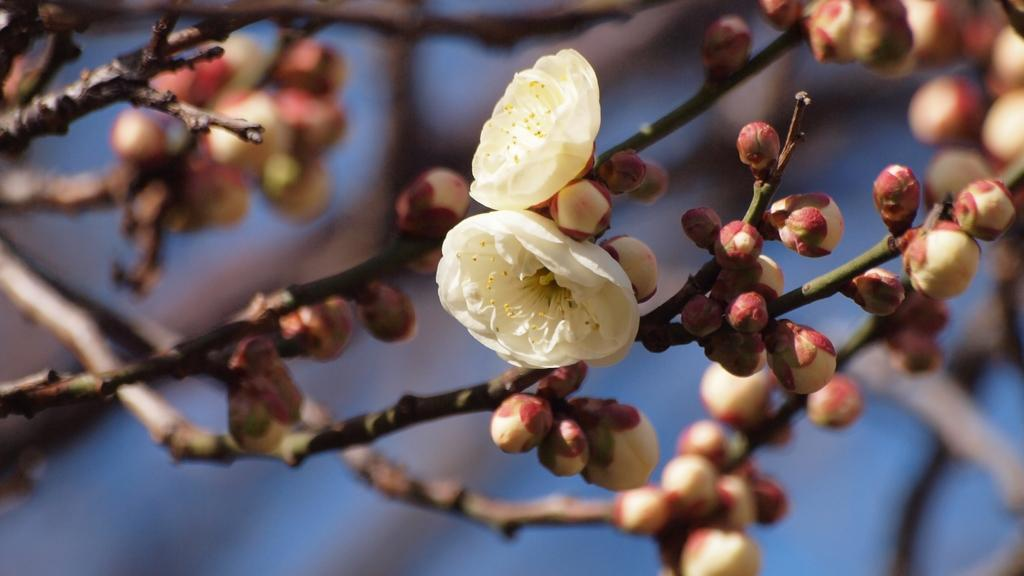How many flowers can be seen in the image? There are two flowers in the image. What color are the flowers? The flowers are cream-colored. Are there any unopened flowers on the plant? Yes, there are flower buds on the plant. What can be observed about the background of the image? The background of the image is blurred. What is the opinion of the hook in the image? There is no hook present in the image, so it is not possible to determine its opinion. 